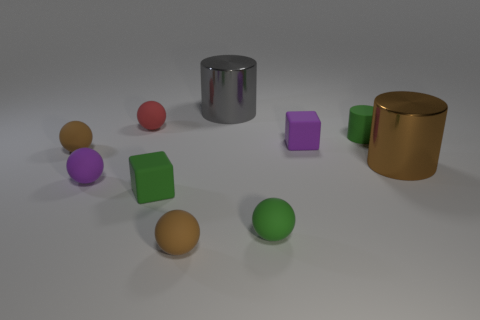What material is the small cube that is the same color as the small rubber cylinder?
Give a very brief answer. Rubber. Are there fewer small purple things to the right of the big brown shiny thing than big objects that are behind the small red matte thing?
Ensure brevity in your answer.  Yes. Are the tiny green sphere and the large gray object made of the same material?
Provide a succinct answer. No. There is a matte object that is both left of the green matte sphere and right of the green cube; what size is it?
Offer a terse response. Small. There is a purple matte thing that is the same size as the purple block; what shape is it?
Provide a short and direct response. Sphere. The tiny block on the left side of the small rubber cube that is right of the small matte sphere in front of the green ball is made of what material?
Your answer should be compact. Rubber. Do the matte thing behind the green rubber cylinder and the purple matte object right of the small red ball have the same shape?
Provide a short and direct response. No. How many other objects are the same material as the tiny purple cube?
Your answer should be compact. 7. Is the large object behind the red matte object made of the same material as the brown ball behind the green matte sphere?
Your answer should be very brief. No. What is the shape of the tiny red object that is made of the same material as the small green ball?
Give a very brief answer. Sphere. 